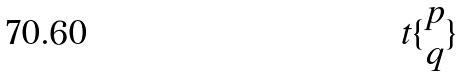<formula> <loc_0><loc_0><loc_500><loc_500>t \{ \begin{matrix} p \\ q \end{matrix} \}</formula> 